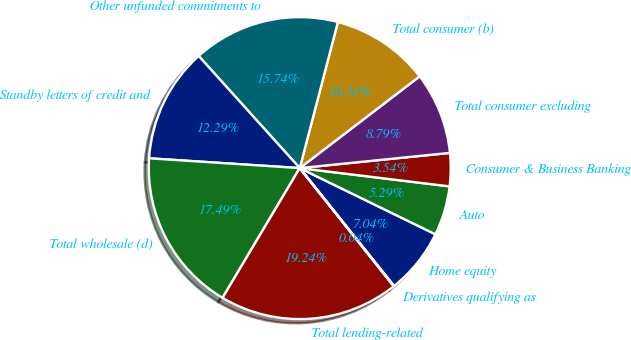<chart> <loc_0><loc_0><loc_500><loc_500><pie_chart><fcel>Home equity<fcel>Auto<fcel>Consumer & Business Banking<fcel>Total consumer excluding<fcel>Total consumer (b)<fcel>Other unfunded commitments to<fcel>Standby letters of credit and<fcel>Total wholesale (d)<fcel>Total lending-related<fcel>Derivatives qualifying as<nl><fcel>7.04%<fcel>5.29%<fcel>3.54%<fcel>8.79%<fcel>10.54%<fcel>15.74%<fcel>12.29%<fcel>17.49%<fcel>19.24%<fcel>0.04%<nl></chart> 